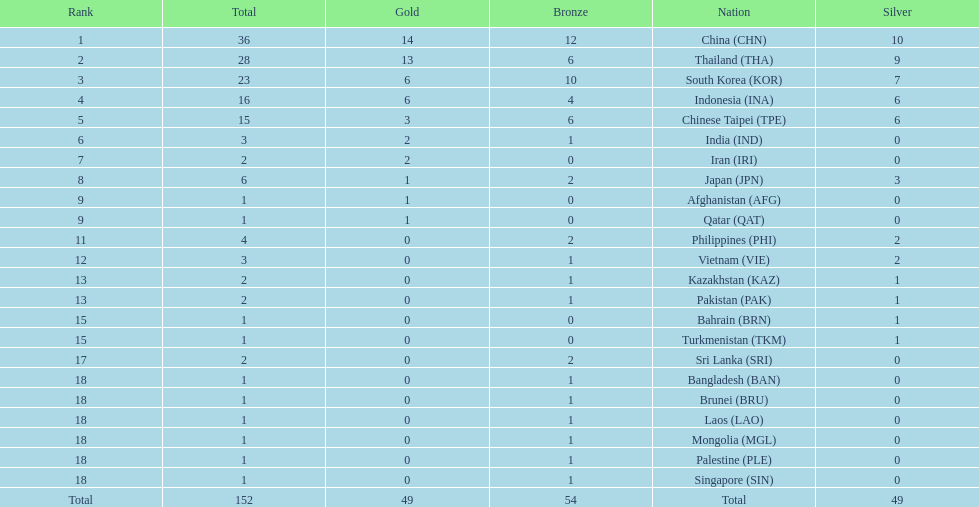How many nations received more than 5 gold medals? 4. 